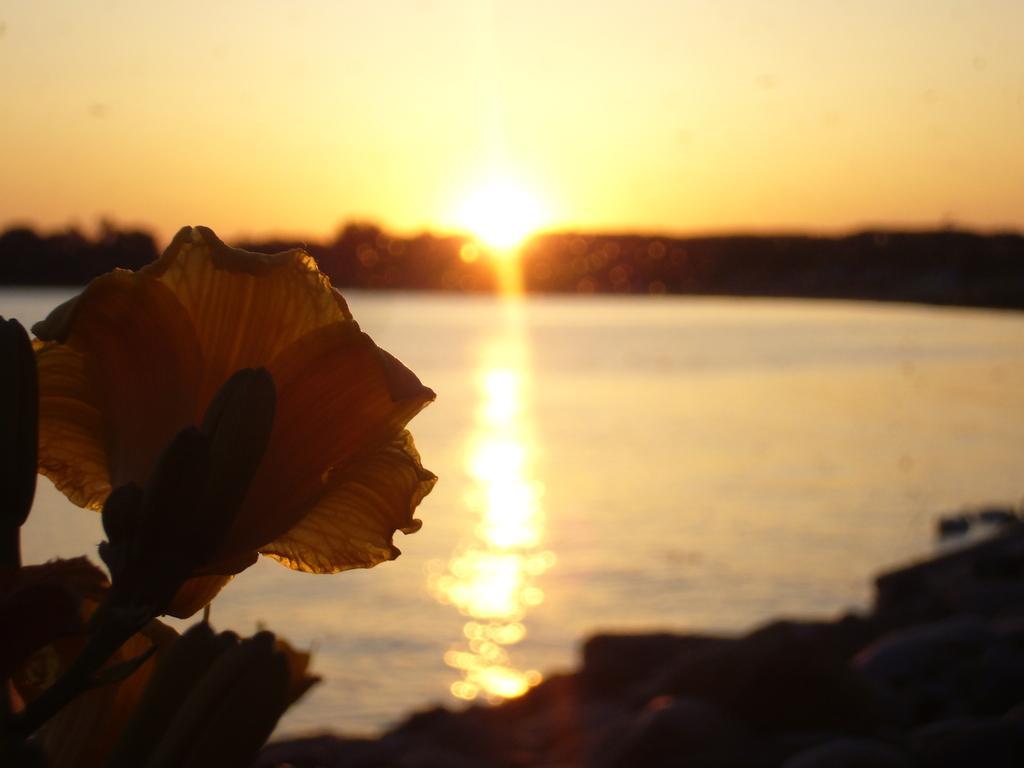Please provide a concise description of this image. In this image we can see a flower and water. In the background we can see sky and sun. 